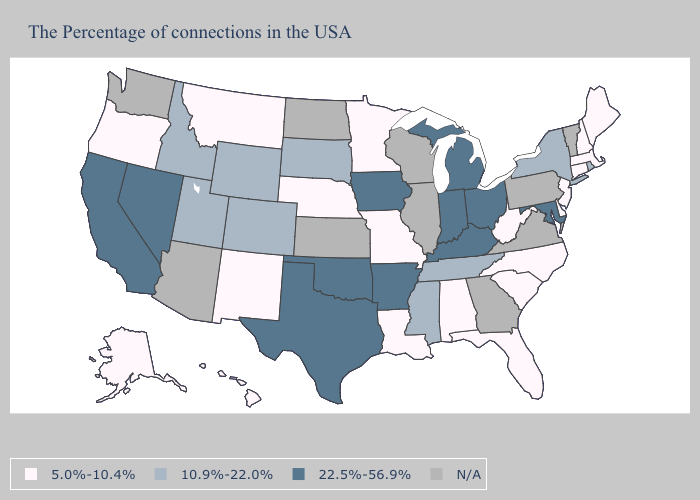What is the value of Louisiana?
Concise answer only. 5.0%-10.4%. Which states have the lowest value in the Northeast?
Concise answer only. Maine, Massachusetts, New Hampshire, Connecticut, New Jersey. Name the states that have a value in the range 5.0%-10.4%?
Keep it brief. Maine, Massachusetts, New Hampshire, Connecticut, New Jersey, Delaware, North Carolina, South Carolina, West Virginia, Florida, Alabama, Louisiana, Missouri, Minnesota, Nebraska, New Mexico, Montana, Oregon, Alaska, Hawaii. What is the value of Wisconsin?
Be succinct. N/A. Which states have the lowest value in the USA?
Short answer required. Maine, Massachusetts, New Hampshire, Connecticut, New Jersey, Delaware, North Carolina, South Carolina, West Virginia, Florida, Alabama, Louisiana, Missouri, Minnesota, Nebraska, New Mexico, Montana, Oregon, Alaska, Hawaii. Among the states that border Texas , does Louisiana have the highest value?
Concise answer only. No. What is the value of Missouri?
Write a very short answer. 5.0%-10.4%. What is the highest value in the USA?
Be succinct. 22.5%-56.9%. How many symbols are there in the legend?
Quick response, please. 4. Name the states that have a value in the range N/A?
Answer briefly. Vermont, Pennsylvania, Virginia, Georgia, Wisconsin, Illinois, Kansas, North Dakota, Arizona, Washington. What is the value of Louisiana?
Be succinct. 5.0%-10.4%. Is the legend a continuous bar?
Short answer required. No. What is the value of New York?
Be succinct. 10.9%-22.0%. 